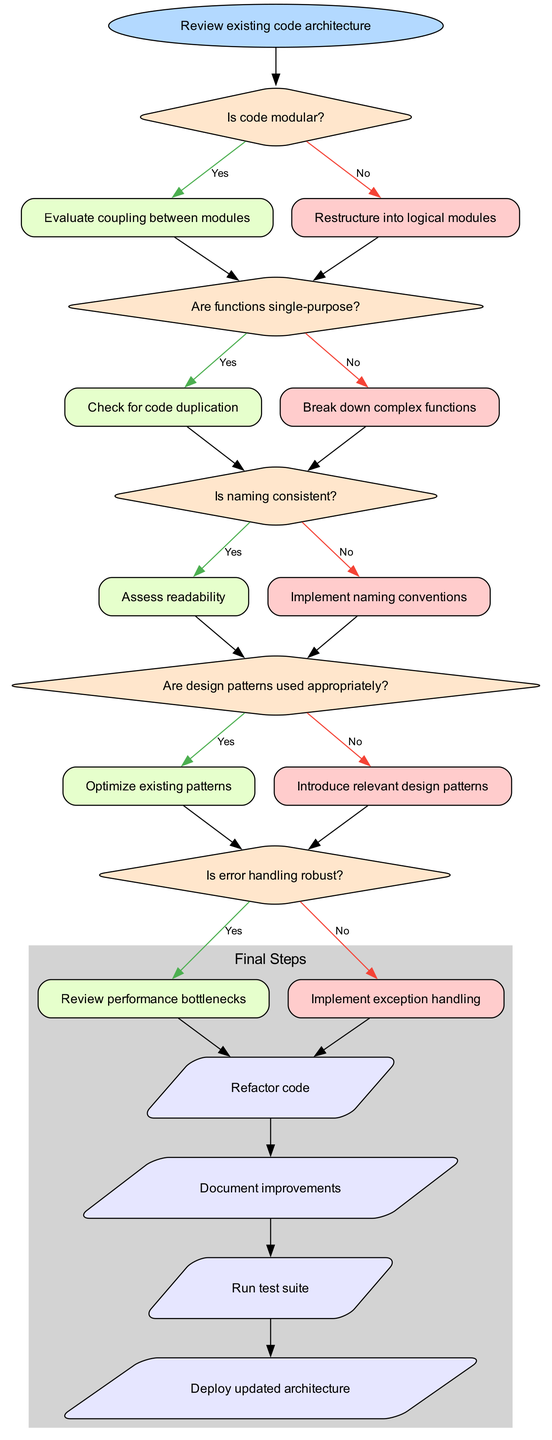What is the starting point of the decision tree? The starting point is labeled as "Review existing code architecture." This is the first node from which all subsequent decisions stem, indicating where the process begins.
Answer: Review existing code architecture How many decisions are present in the flow chart? There are five decision nodes shown in the diagram. Each decision node corresponds to a key question about the code architecture that guides the refactoring process.
Answer: 5 What is the consequence of a 'No' answer to the first question? A 'No' answer to the first question ("Is code modular?") leads to the instruction to "Restructure into logical modules." This action addresses the identified issue of modularity in the code.
Answer: Restructure into logical modules What follows after a 'Yes' answer to the last decision about error handling? After a 'Yes' answer to the last decision on error handling, the next step is "Review performance bottlenecks." This indicates that the system moves forward to assess performance if error handling is deemed robust.
Answer: Review performance bottlenecks If all decisions yield 'No', what should be the final step? If all decisions yield 'No', the final step to follow is "Refactor code." This pertains to addressing shortcomings outlined in each decision by implementing necessary changes.
Answer: Refactor code What type of shapes are used for the decision nodes? The decision nodes are represented by diamond shapes, which is a standard convention in flowcharts to indicate decision points requiring a 'Yes' or 'No' answer.
Answer: Diamond shapes What is the significance of parallelogram shapes in the flow chart? The parallelogram shapes in the flow chart represent the endpoints or final actions to be taken once the decision-making process is complete, indicating outcomes of the refactoring process.
Answer: Final actions How does the flowchart handle code duplication? The flowchart addresses code duplication by asking, "Are functions single-purpose?" If not, the recommended action is to "Break down complex functions" to eliminate redundancy in the code.
Answer: Break down complex functions What happens if the naming in the code is not consistent? If the naming in the code is not consistent, the action to implement is "Implement naming conventions," which aims to standardize code readability and usability.
Answer: Implement naming conventions 